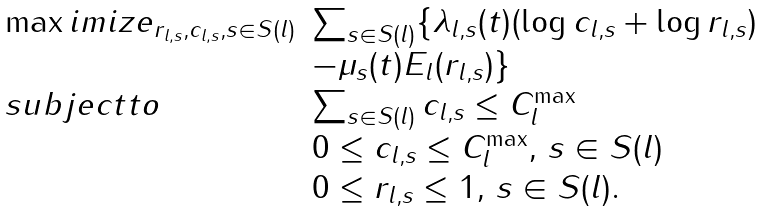<formula> <loc_0><loc_0><loc_500><loc_500>\begin{array} { l l } \max i m i z e _ { r _ { l , s } , c _ { l , s } , s \in S ( l ) } & \sum _ { s \in S ( l ) } \{ \lambda _ { l , s } ( t ) ( \log { c _ { l , s } } + \log { r _ { l , s } } ) \\ & - \mu _ { s } ( t ) E _ { l } ( r _ { l , s } ) \} \\ s u b j e c t t o & \sum _ { s \in S ( l ) } c _ { l , s } \leq C _ { l } ^ { \max } \\ & 0 \leq c _ { l , s } \leq C _ { l } ^ { \max } , \, s \in S ( l ) \\ & 0 \leq r _ { l , s } \leq 1 , \, s \in S ( l ) . \end{array}</formula> 